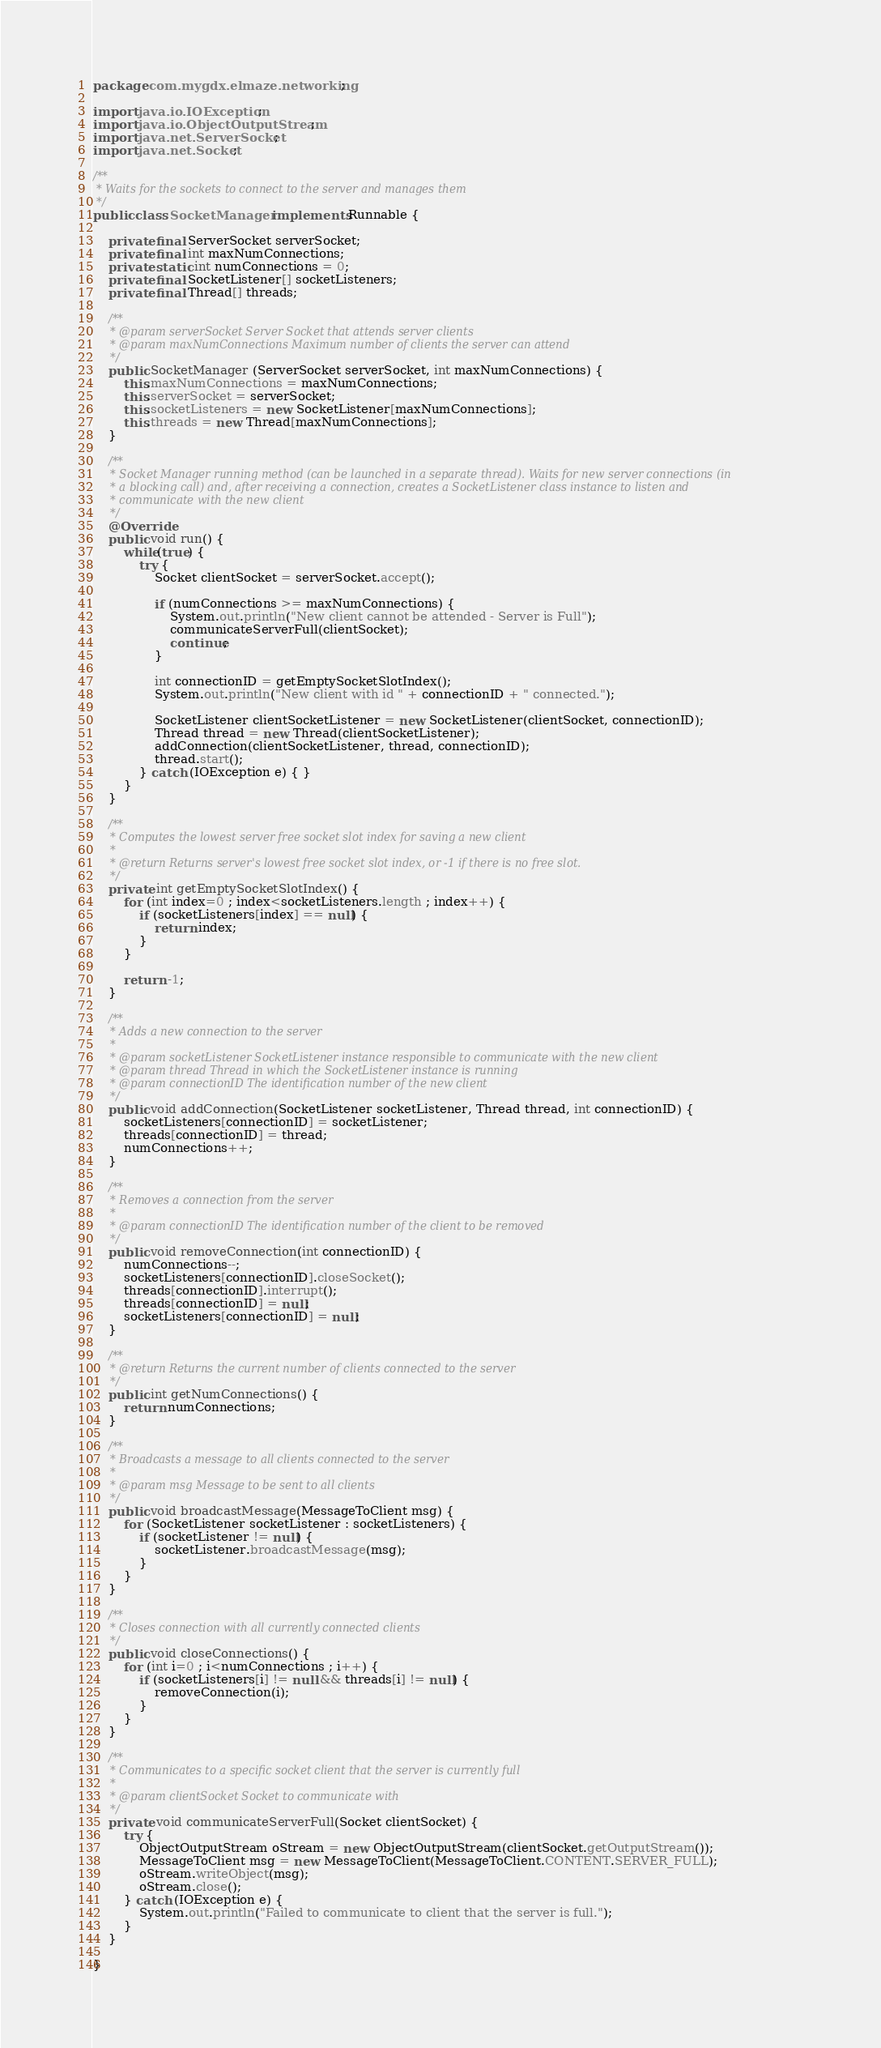<code> <loc_0><loc_0><loc_500><loc_500><_Java_>package com.mygdx.elmaze.networking;

import java.io.IOException;
import java.io.ObjectOutputStream;
import java.net.ServerSocket;
import java.net.Socket;

/**
 * Waits for the sockets to connect to the server and manages them
 */
public class SocketManager implements Runnable {
	
	private final ServerSocket serverSocket;
	private final int maxNumConnections;
	private static int numConnections = 0;
	private final SocketListener[] socketListeners;
	private final Thread[] threads;
	
	/**
	 * @param serverSocket Server Socket that attends server clients
	 * @param maxNumConnections Maximum number of clients the server can attend
	 */
	public SocketManager (ServerSocket serverSocket, int maxNumConnections) {
		this.maxNumConnections = maxNumConnections;
		this.serverSocket = serverSocket;
		this.socketListeners = new SocketListener[maxNumConnections];
		this.threads = new Thread[maxNumConnections];
	}

	/**
	 * Socket Manager running method (can be launched in a separate thread). Waits for new server connections (in
	 * a blocking call) and, after receiving a connection, creates a SocketListener class instance to listen and 
	 * communicate with the new client
	 */
	@Override
	public void run() {
		while(true) {
			try {
				Socket clientSocket = serverSocket.accept();

				if (numConnections >= maxNumConnections) {
					System.out.println("New client cannot be attended - Server is Full");
					communicateServerFull(clientSocket);
					continue;
				}

				int connectionID = getEmptySocketSlotIndex();
				System.out.println("New client with id " + connectionID + " connected.");
				
				SocketListener clientSocketListener = new SocketListener(clientSocket, connectionID);
				Thread thread = new Thread(clientSocketListener);
				addConnection(clientSocketListener, thread, connectionID);
				thread.start();
			} catch (IOException e) { }
		}
	}
	
	/**
	 * Computes the lowest server free socket slot index for saving a new client
	 * 
	 * @return Returns server's lowest free socket slot index, or -1 if there is no free slot.
	 */
	private int getEmptySocketSlotIndex() {
		for (int index=0 ; index<socketListeners.length ; index++) {
			if (socketListeners[index] == null) {
				return index;
			}
		}
		
		return -1;
	}
	
	/**
	 * Adds a new connection to the server
	 * 
	 * @param socketListener SocketListener instance responsible to communicate with the new client
	 * @param thread Thread in which the SocketListener instance is running
	 * @param connectionID The identification number of the new client
	 */
	public void addConnection(SocketListener socketListener, Thread thread, int connectionID) {
		socketListeners[connectionID] = socketListener;
		threads[connectionID] = thread;
		numConnections++;
	}
	
	/**
	 * Removes a connection from the server
	 * 
	 * @param connectionID The identification number of the client to be removed
	 */
	public void removeConnection(int connectionID) {
		numConnections--;
		socketListeners[connectionID].closeSocket();
		threads[connectionID].interrupt();
		threads[connectionID] = null;
		socketListeners[connectionID] = null;
	}
	
	/**
	 * @return Returns the current number of clients connected to the server
	 */
	public int getNumConnections() {
		return numConnections;
	}
	
	/**
	 * Broadcasts a message to all clients connected to the server
	 * 
	 * @param msg Message to be sent to all clients
	 */
	public void broadcastMessage(MessageToClient msg) {
		for (SocketListener socketListener : socketListeners) {
			if (socketListener != null) {
				socketListener.broadcastMessage(msg);
			}
		}
	}
	
	/**
	 * Closes connection with all currently connected clients
	 */
	public void closeConnections() {
		for (int i=0 ; i<numConnections ; i++) {
			if (socketListeners[i] != null && threads[i] != null) {
				removeConnection(i);
			}
		}
	}
	
	/**
	 * Communicates to a specific socket client that the server is currently full
	 * 
	 * @param clientSocket Socket to communicate with
	 */
	private void communicateServerFull(Socket clientSocket) {
		try {
			ObjectOutputStream oStream = new ObjectOutputStream(clientSocket.getOutputStream());
			MessageToClient msg = new MessageToClient(MessageToClient.CONTENT.SERVER_FULL);
            oStream.writeObject(msg);
            oStream.close();
		} catch (IOException e) {
			System.out.println("Failed to communicate to client that the server is full.");
		}
	}
	
}
</code> 